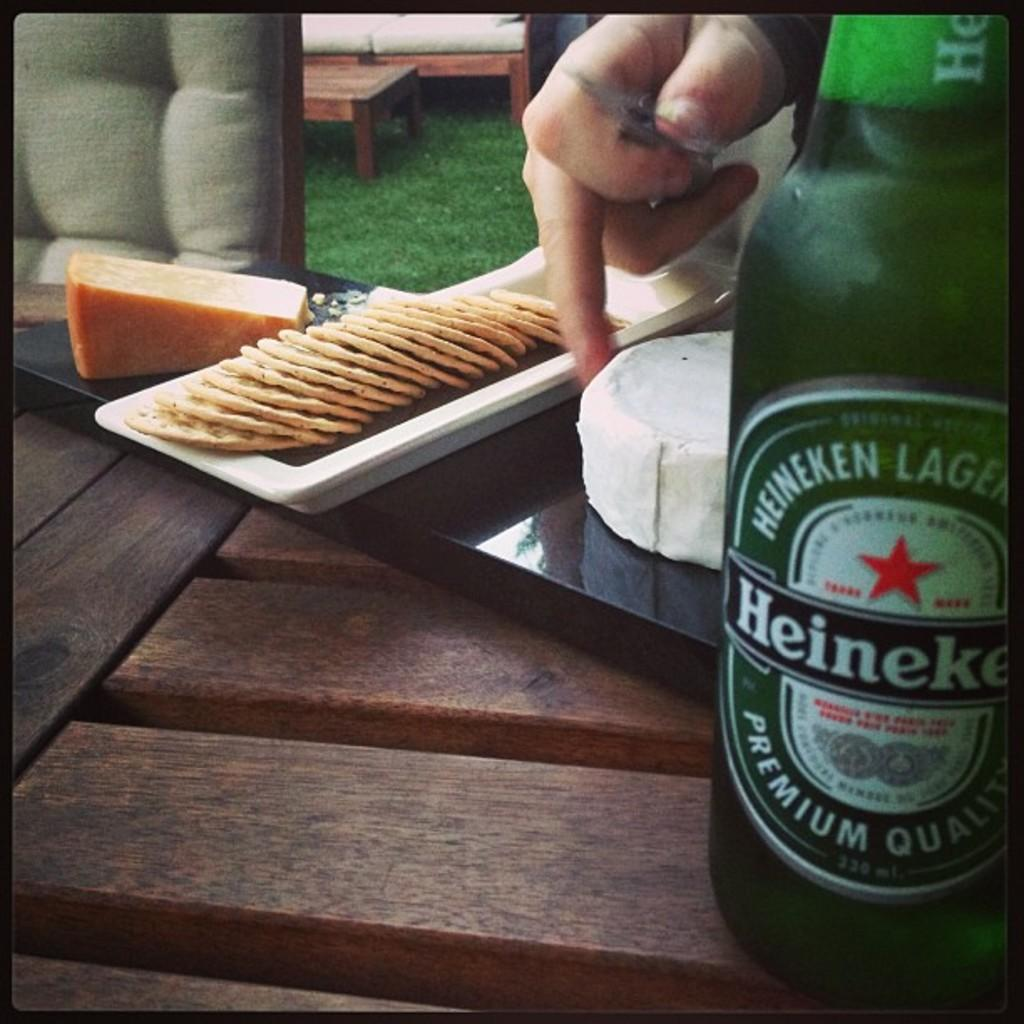<image>
Present a compact description of the photo's key features. Food sitting next to a bottle of Heinenken Lager. 